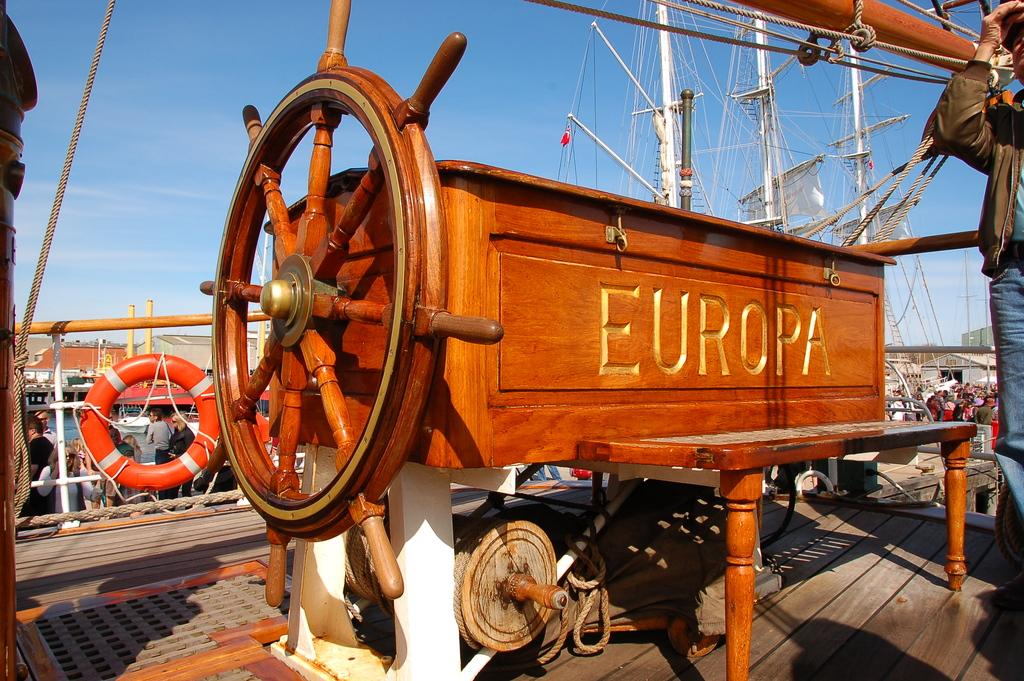What object is the main focus of the image? There is a boat steering wheel in the image. Can you describe the person in the image? There is a man standing in the image. What arithmetic problem is the man solving in the image? There is no arithmetic problem visible in the image. What type of beast can be seen accompanying the man in the image? There is no beast present in the image; only the man and the boat steering wheel are visible. 